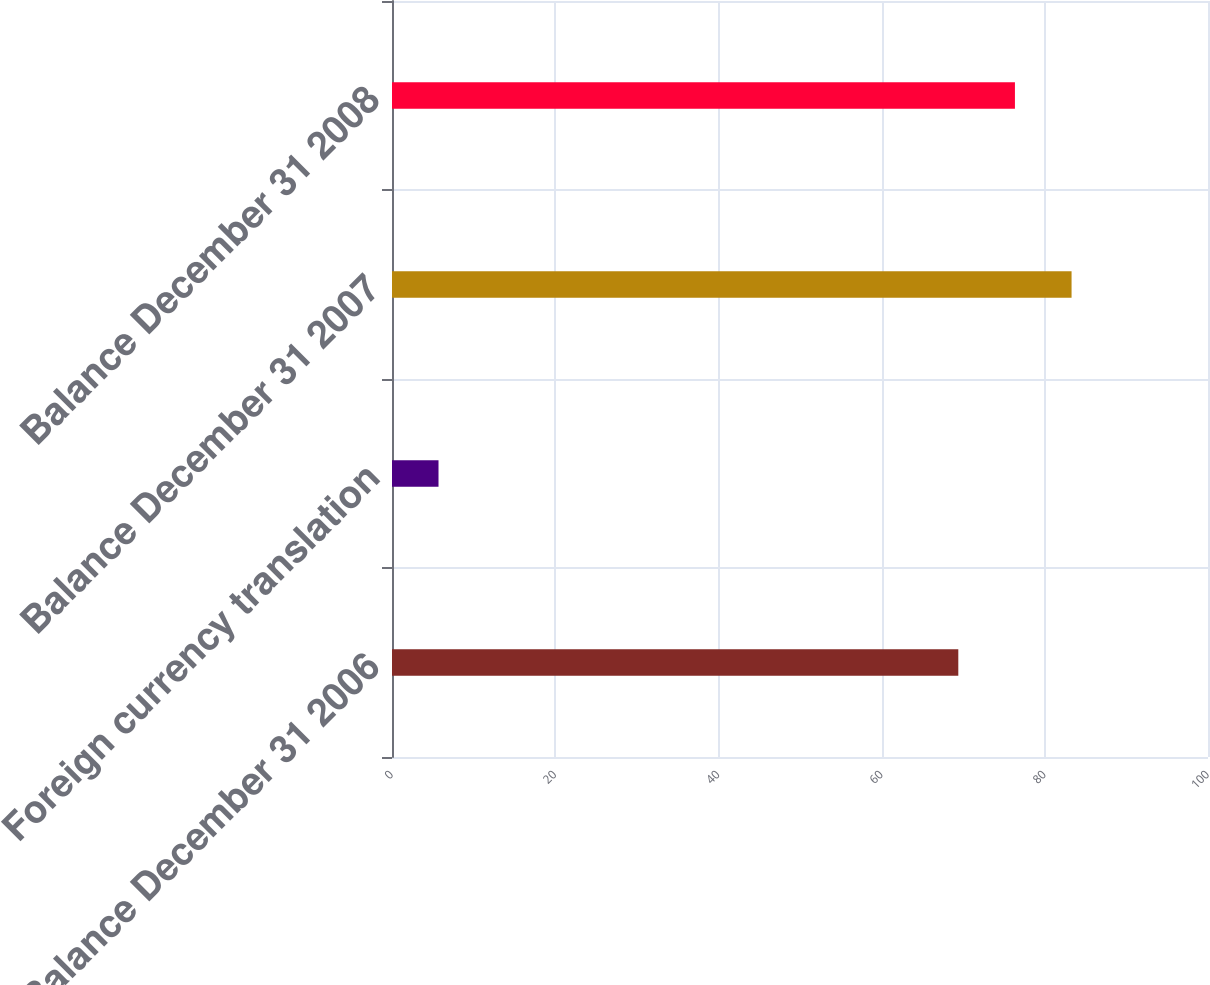Convert chart to OTSL. <chart><loc_0><loc_0><loc_500><loc_500><bar_chart><fcel>Balance December 31 2006<fcel>Foreign currency translation<fcel>Balance December 31 2007<fcel>Balance December 31 2008<nl><fcel>69.4<fcel>5.7<fcel>83.28<fcel>76.34<nl></chart> 